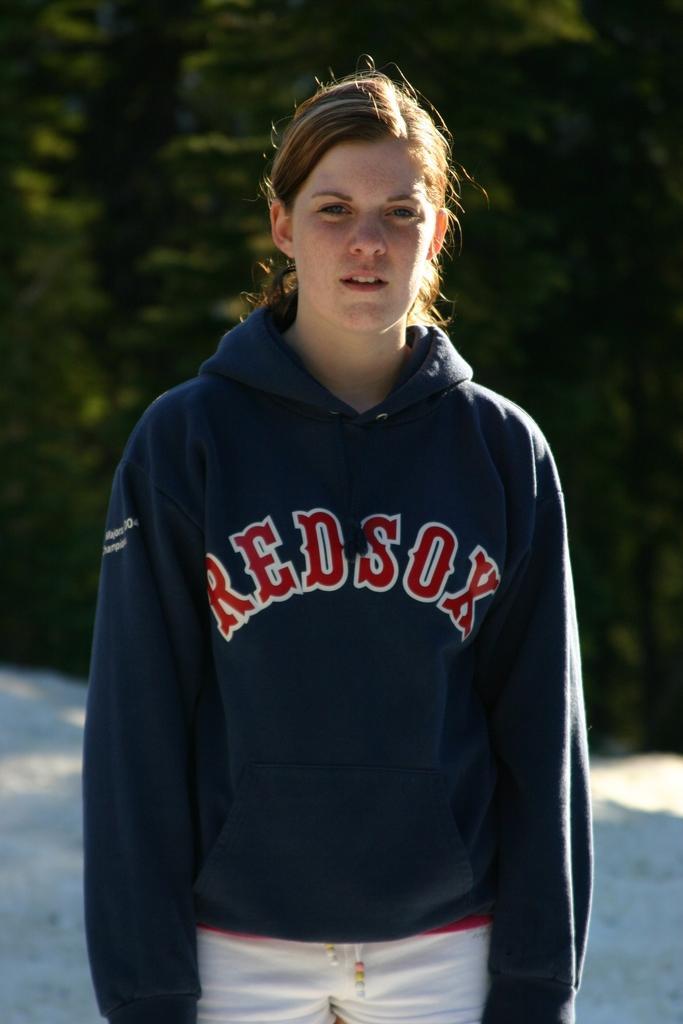In one or two sentences, can you explain what this image depicts? In the image a woman is standing. Behind her there are some trees. 